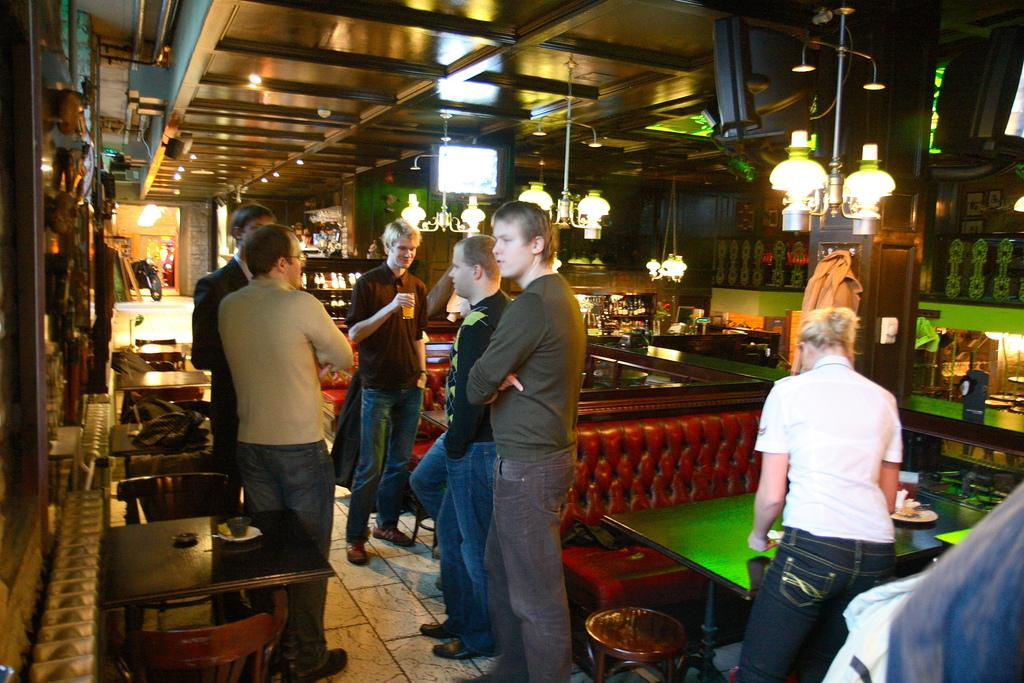What can be seen in the image? There are people standing in the image. What furniture is present in the image? There is a table and a chair in the image. What can be seen in the background of the image? There are objects visible in the background of the image. What type of honey is being poured from the square container in the image? There is no honey or square container present in the image. 